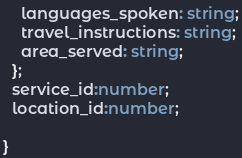Convert code to text. <code><loc_0><loc_0><loc_500><loc_500><_TypeScript_>    languages_spoken: string;
    travel_instructions: string;
    area_served: string;
  };
  service_id:number;
  location_id:number;

}
</code> 